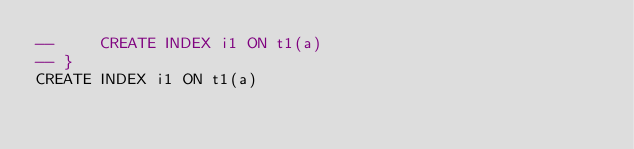Convert code to text. <code><loc_0><loc_0><loc_500><loc_500><_SQL_>--     CREATE INDEX i1 ON t1(a)
-- }
CREATE INDEX i1 ON t1(a)</code> 